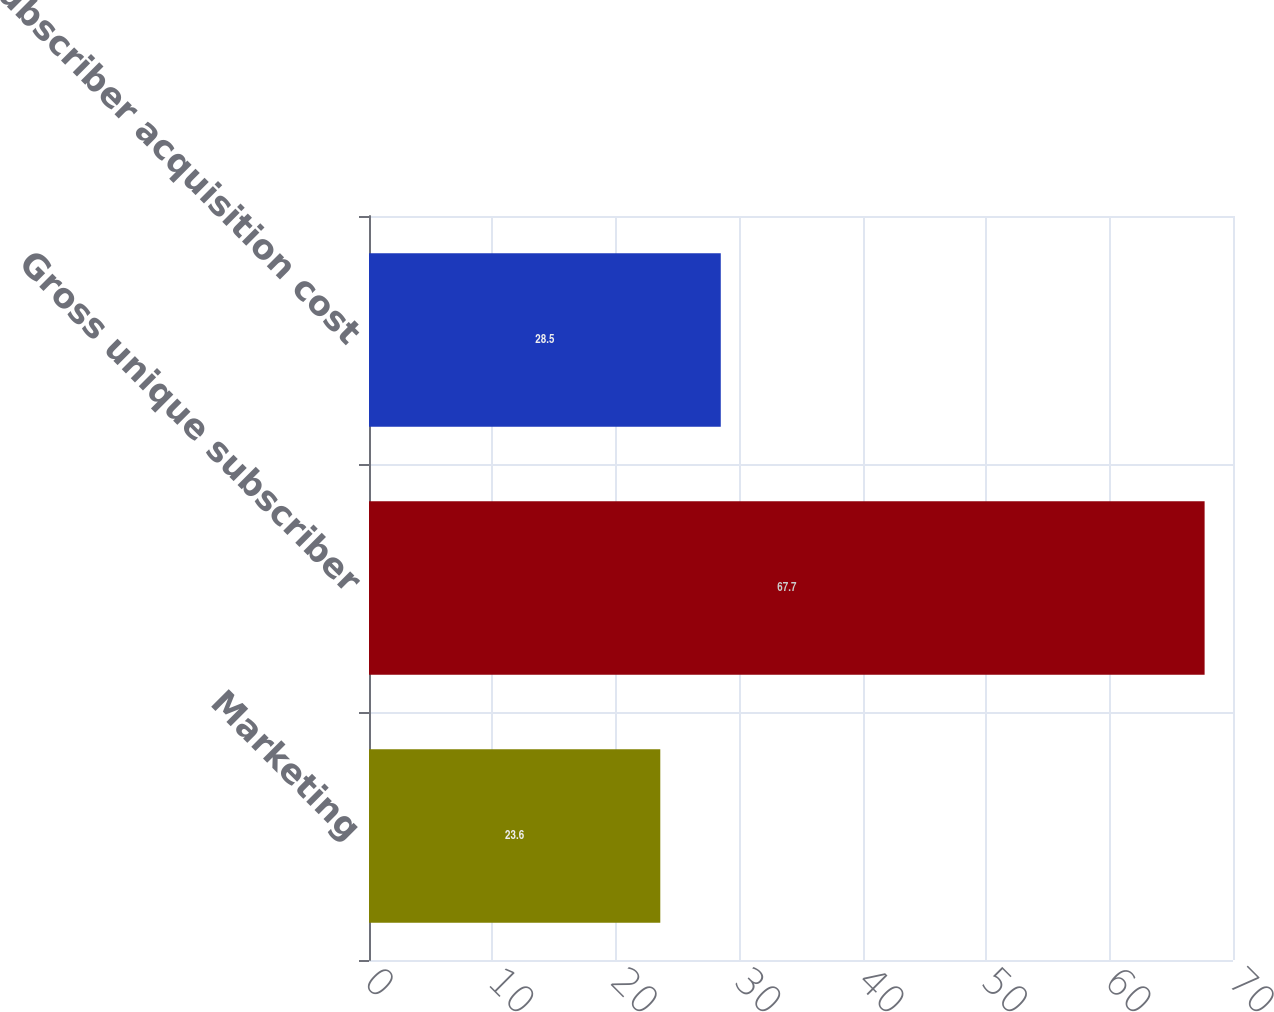<chart> <loc_0><loc_0><loc_500><loc_500><bar_chart><fcel>Marketing<fcel>Gross unique subscriber<fcel>Subscriber acquisition cost<nl><fcel>23.6<fcel>67.7<fcel>28.5<nl></chart> 